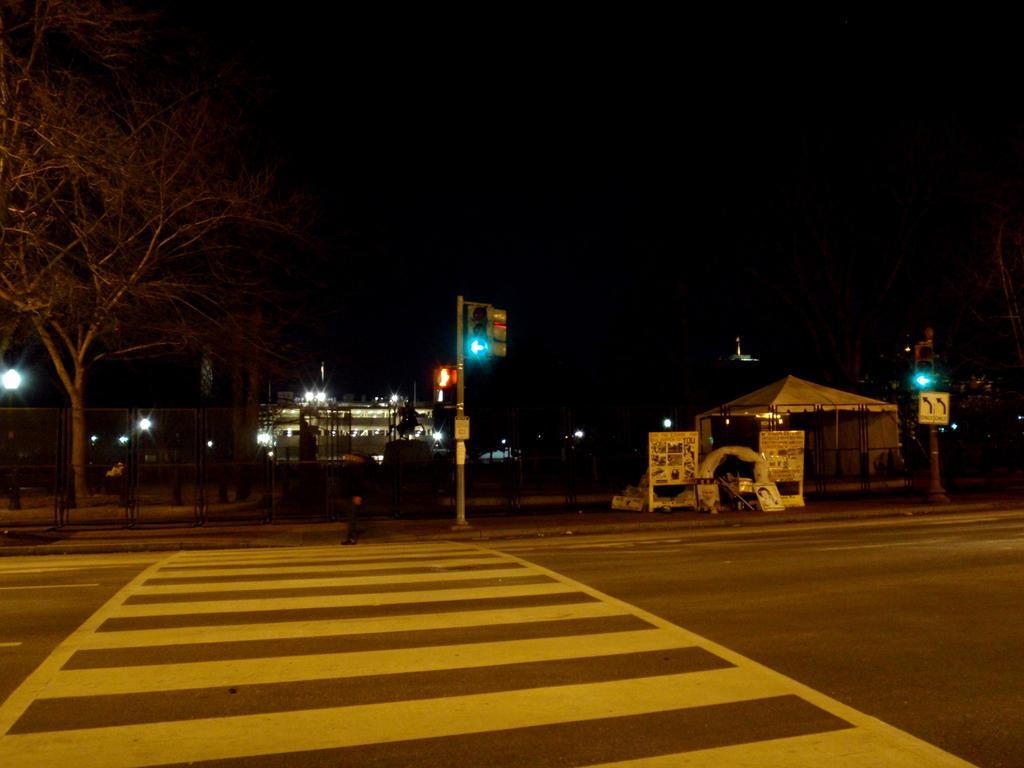Describe this image in one or two sentences. In the foreground of the picture we can see the zebra crossing on the road. In the center of the picture there are signal lights, tree, footpath, person, boards, canopy and other objects. In the background we can see building, lights and other objects. At the top it is dark. 